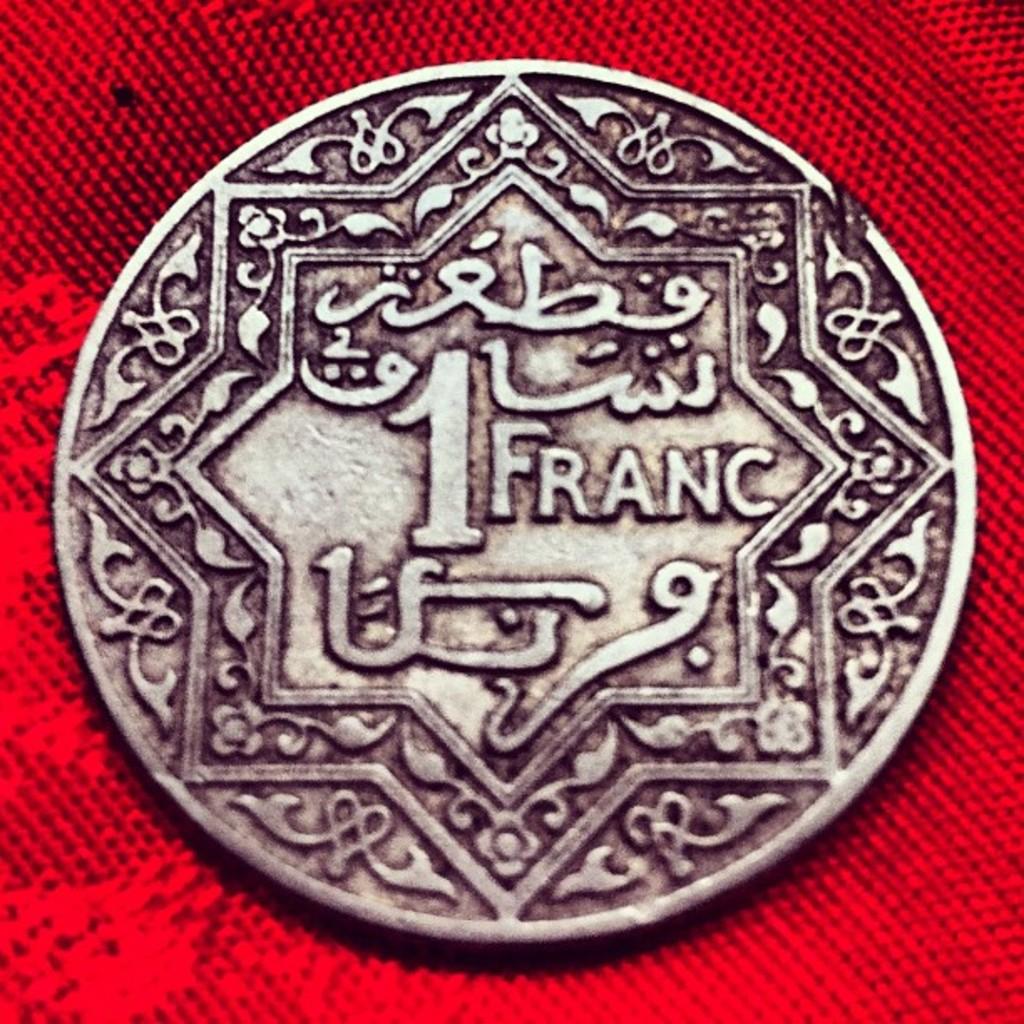Which currency is this?
Offer a terse response. Franc. What is the value of this coin?
Offer a very short reply. 1 franc. 